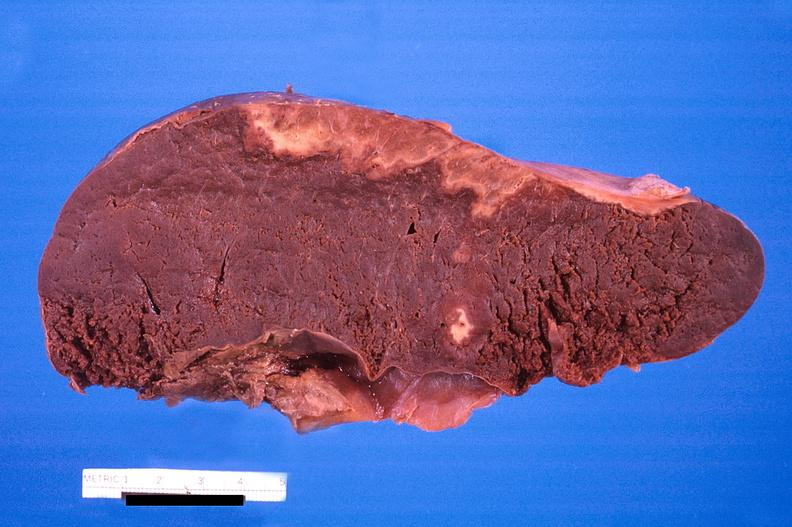s hematologic present?
Answer the question using a single word or phrase. Yes 